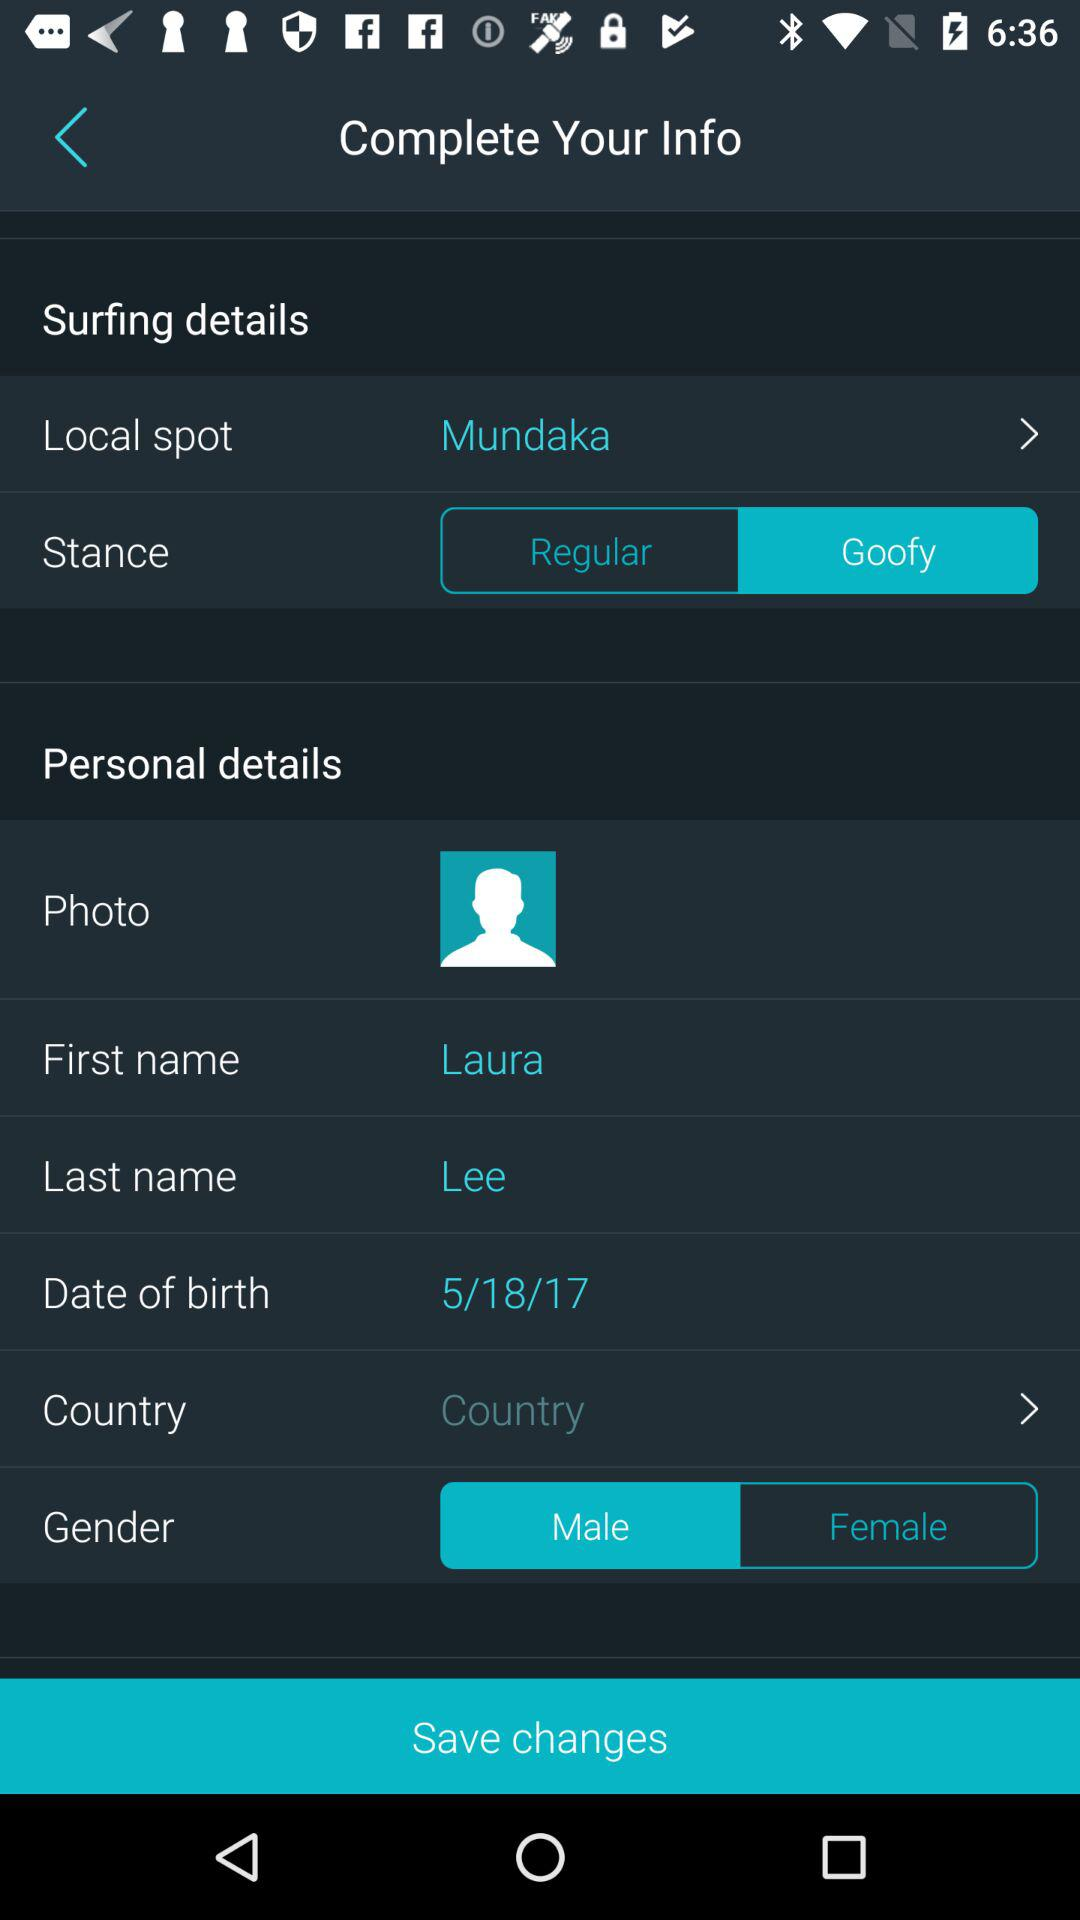What is the selected local spot? The selected local spot is "Mundaka". 